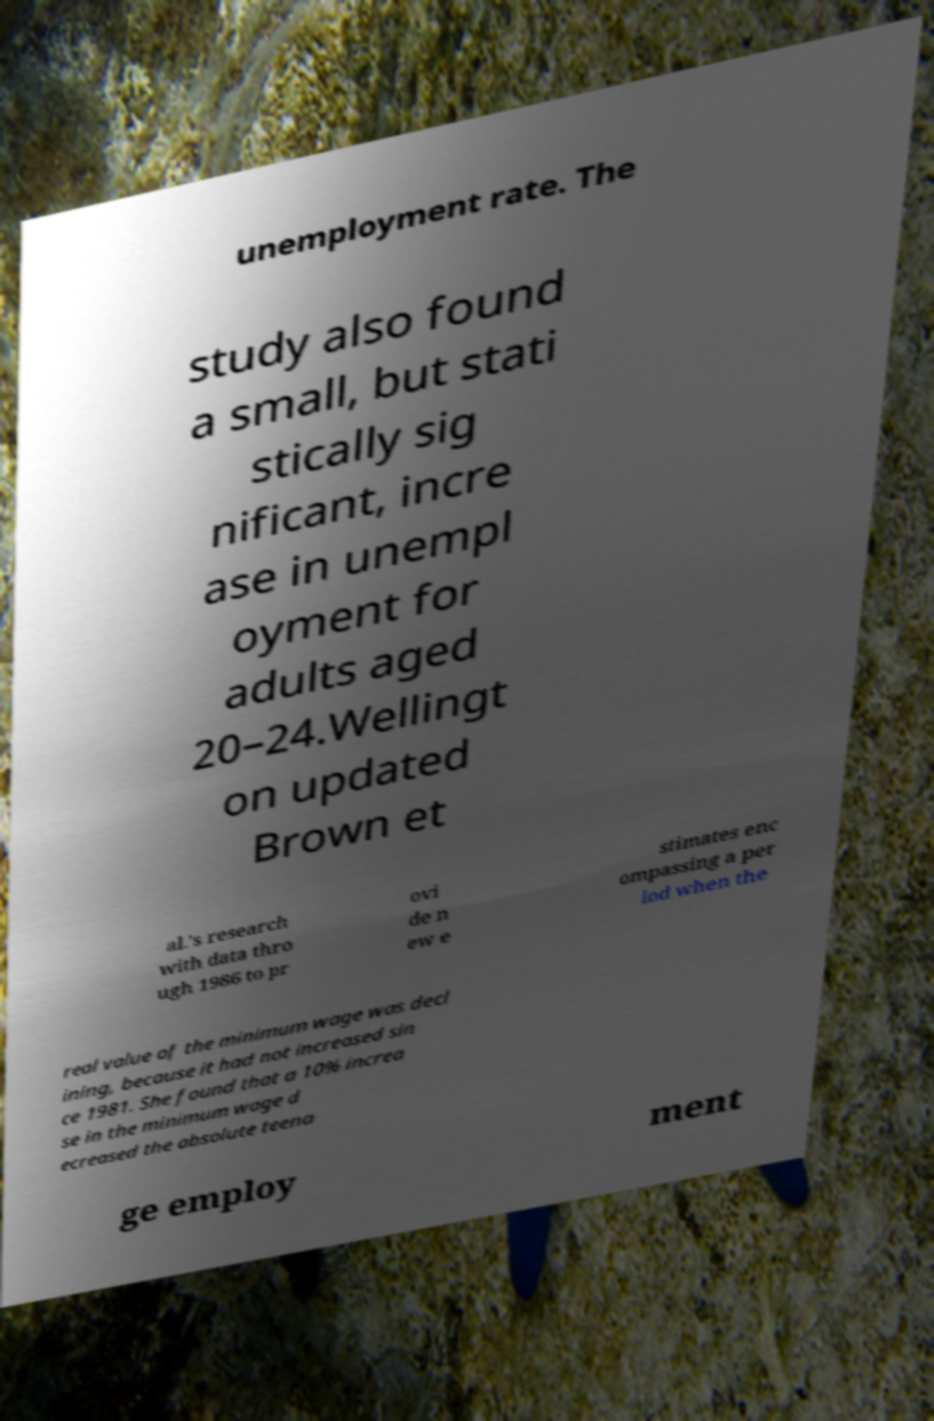Can you read and provide the text displayed in the image?This photo seems to have some interesting text. Can you extract and type it out for me? unemployment rate. The study also found a small, but stati stically sig nificant, incre ase in unempl oyment for adults aged 20–24.Wellingt on updated Brown et al.'s research with data thro ugh 1986 to pr ovi de n ew e stimates enc ompassing a per iod when the real value of the minimum wage was decl ining, because it had not increased sin ce 1981. She found that a 10% increa se in the minimum wage d ecreased the absolute teena ge employ ment 